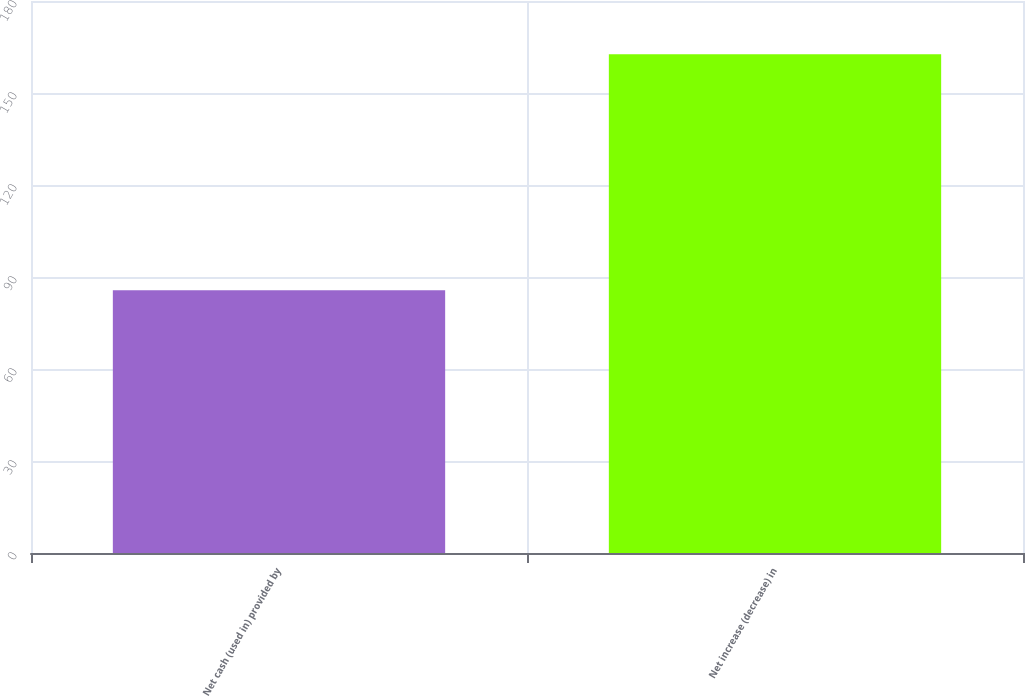Convert chart to OTSL. <chart><loc_0><loc_0><loc_500><loc_500><bar_chart><fcel>Net cash (used in) provided by<fcel>Net increase (decrease) in<nl><fcel>85.7<fcel>162.6<nl></chart> 